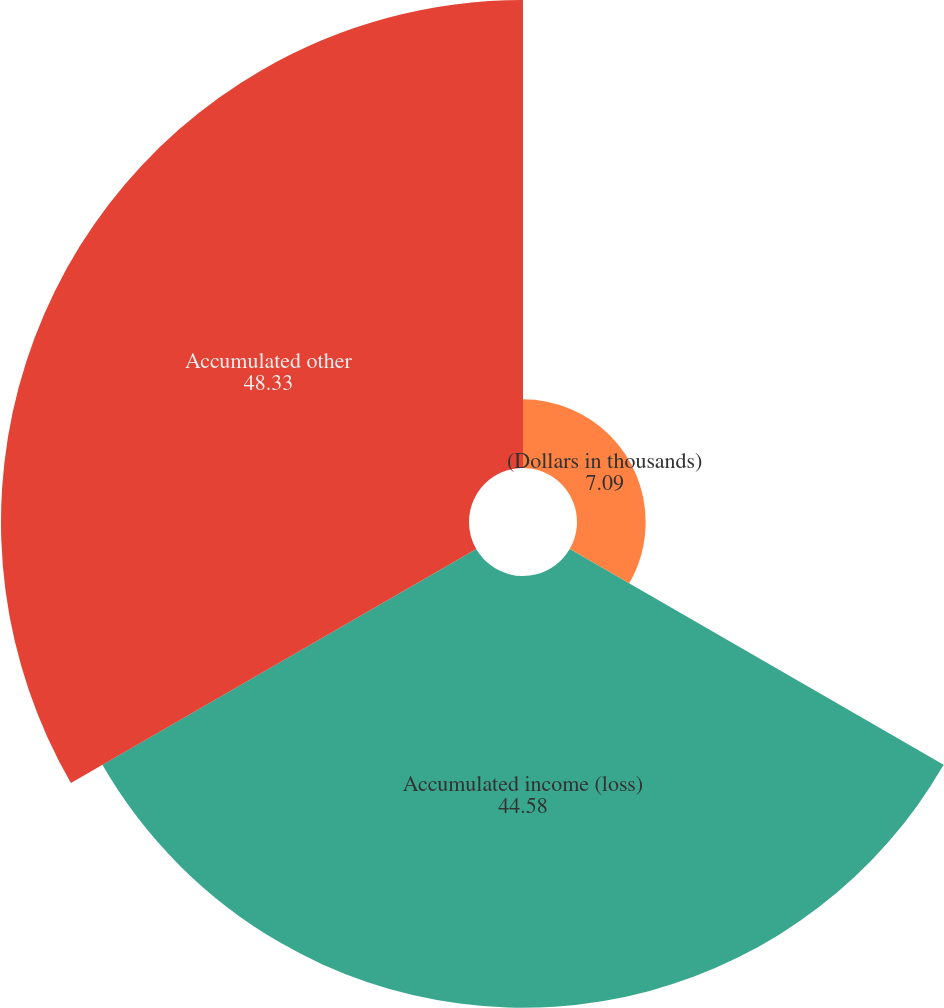Convert chart. <chart><loc_0><loc_0><loc_500><loc_500><pie_chart><fcel>(Dollars in thousands)<fcel>Accumulated income (loss)<fcel>Accumulated other<nl><fcel>7.09%<fcel>44.58%<fcel>48.33%<nl></chart> 